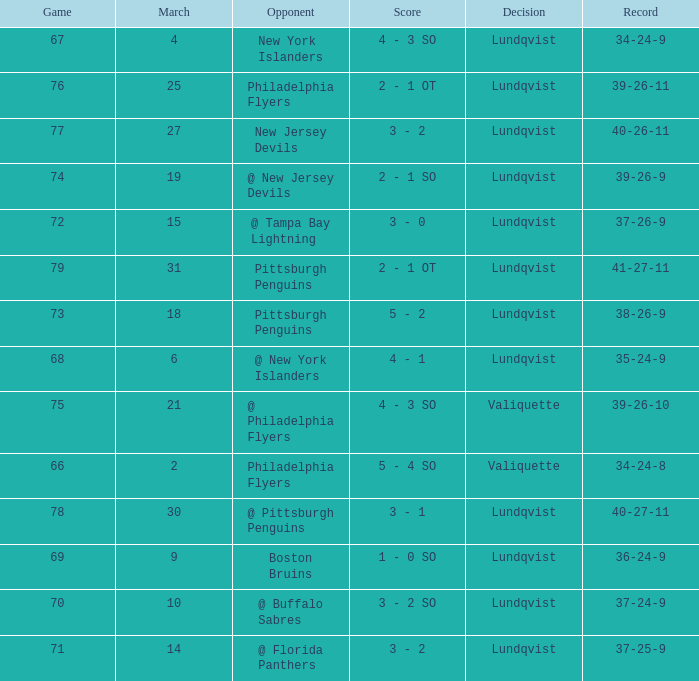Which score's game was less than 69 when the march was bigger than 2 and the opponents were the New York Islanders? 4 - 3 SO. 